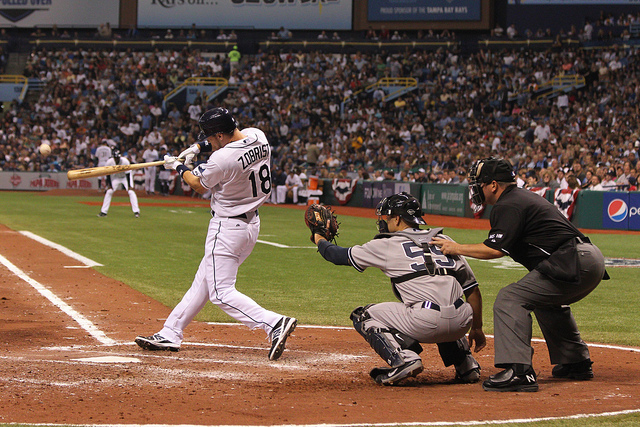Please identify all text content in this image. ZOBRISI P 55 18 